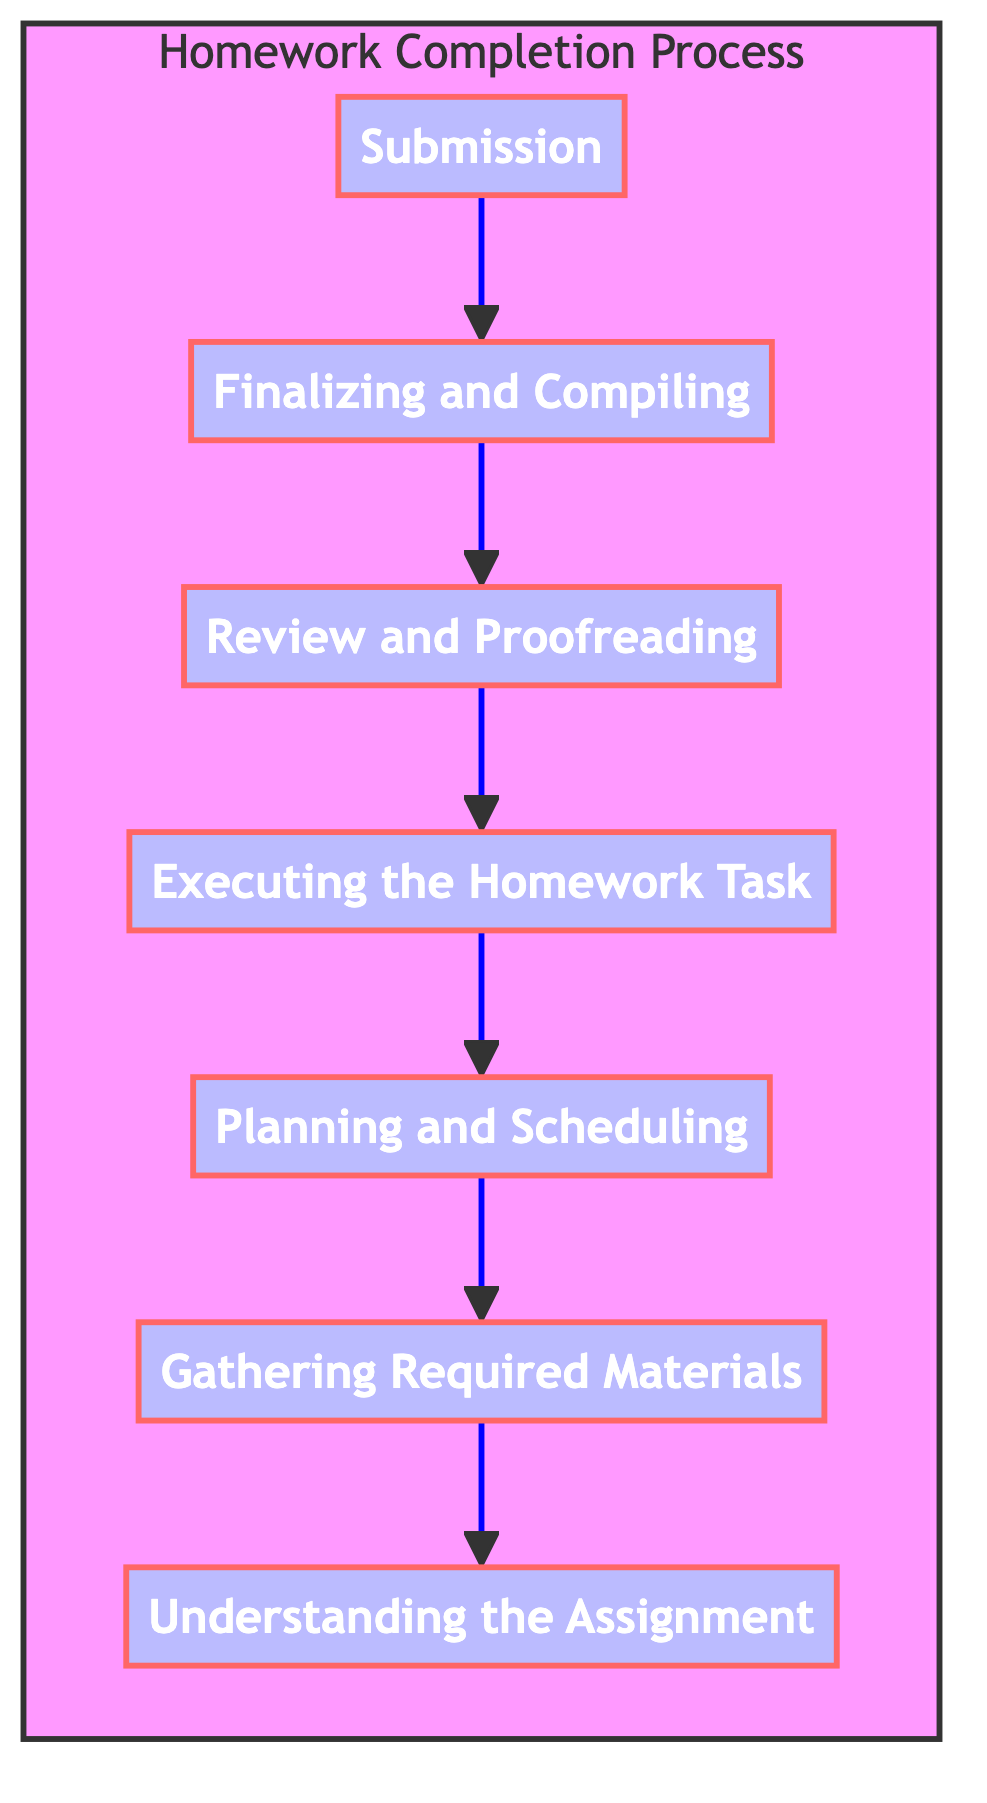What is the first step in the Homework Completion Process? In the flowchart, the first step at the top is the first stage of completion, which is the "Submission" node.
Answer: Submission How many steps are there in total in the Homework Completion Process? Counting each node in the flowchart, there are seven steps listed, from "Understanding the Assignment" to "Submission."
Answer: Seven What step immediately follows "Review and Proofreading"? Looking at the arrows in the flowchart, the step that comes directly after "Review and Proofreading" is "Finalizing and Compiling."
Answer: Finalizing and Compiling Which two steps are directly connected to "Executing the Homework Task"? The flowchart shows that "Executing the Homework Task" has one arrow leading to it from "Planning and Scheduling," and one arrow leading down to "Review and Proofreading."
Answer: Planning and Scheduling, Review and Proofreading What is the last step before "Submission"? In the flowchart, the step prior to "Submission" is "Finalizing and Compiling," as indicated by the upward arrow pointing towards "Submission."
Answer: Finalizing and Compiling If a student has completed "Gathering Required Materials," what is the next step they should take? The diagram indicates that after "Gathering Required Materials," the student should move forward to "Planning and Scheduling."
Answer: Planning and Scheduling Which step must be completed before "Executing the Homework Task"? The flowchart's connections show that one must first go through "Planning and Scheduling" before reaching the "Executing the Homework Task" step.
Answer: Planning and Scheduling What is the significance of the flow direction in this diagram? The flow direction from bottom to top indicates the sequential order of processes, showing that each step builds upon the previous one, culminating in the final "Submission."
Answer: Sequential order What is the relationship between "Understanding the Assignment" and the overall process? "Understanding the Assignment" is the foundational step at the beginning of the flow, necessary to begin the entire homework completion process, providing context for all subsequent steps.
Answer: Foundational step 